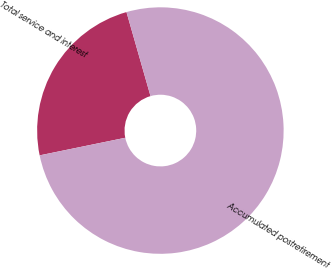Convert chart. <chart><loc_0><loc_0><loc_500><loc_500><pie_chart><fcel>Total service and interest<fcel>Accumulated postretirement<nl><fcel>23.79%<fcel>76.21%<nl></chart> 